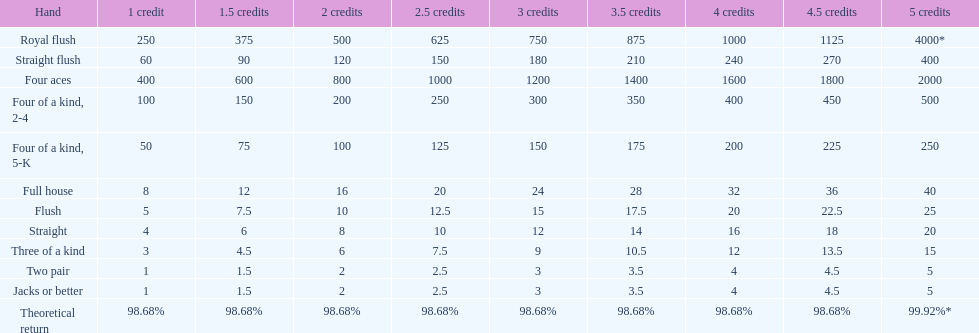Is four 5s worth more or less than four 2s? Less. 